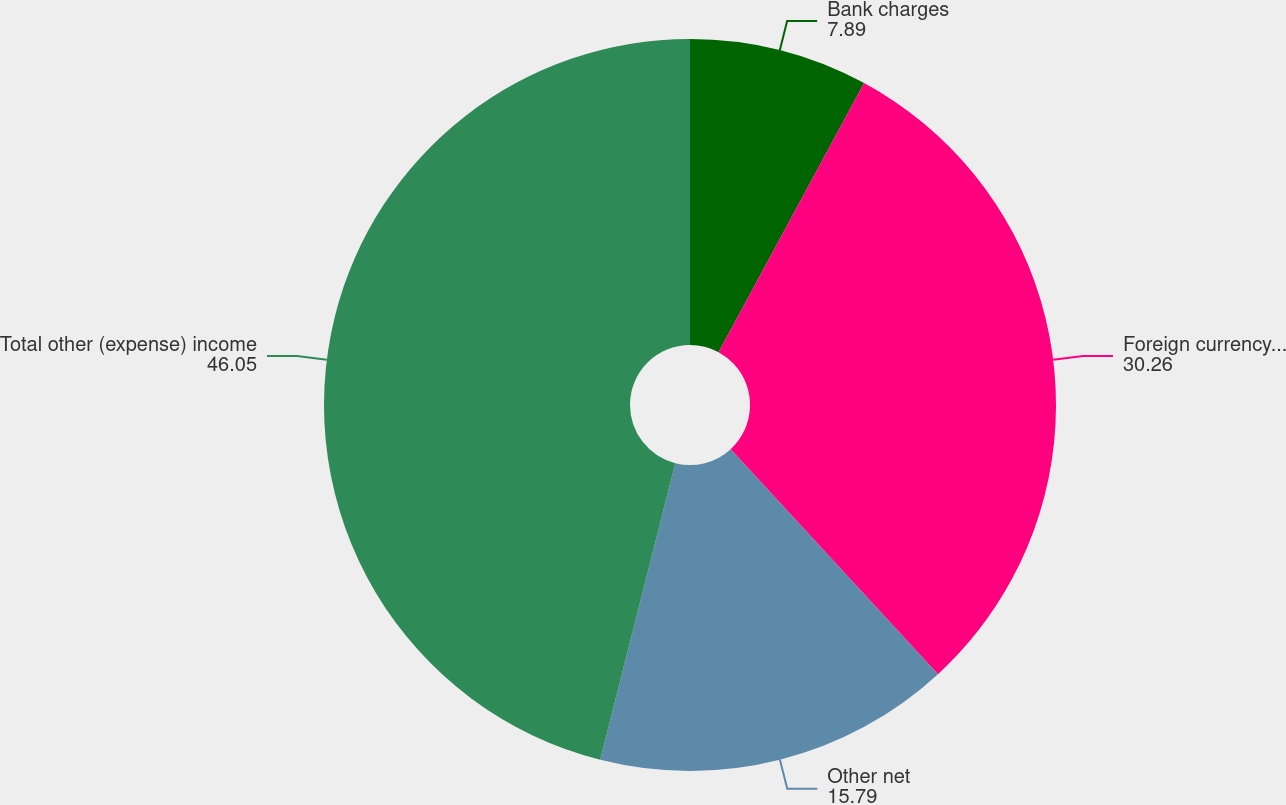Convert chart. <chart><loc_0><loc_0><loc_500><loc_500><pie_chart><fcel>Bank charges<fcel>Foreign currency (losses)<fcel>Other net<fcel>Total other (expense) income<nl><fcel>7.89%<fcel>30.26%<fcel>15.79%<fcel>46.05%<nl></chart> 